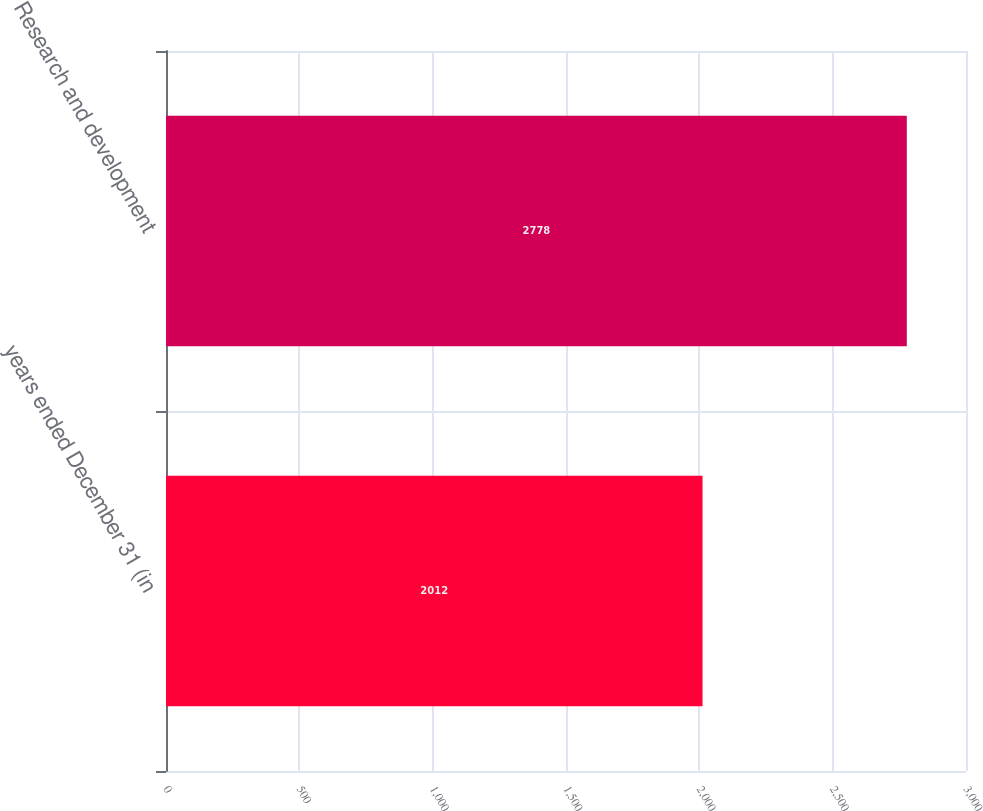<chart> <loc_0><loc_0><loc_500><loc_500><bar_chart><fcel>years ended December 31 (in<fcel>Research and development<nl><fcel>2012<fcel>2778<nl></chart> 